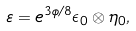Convert formula to latex. <formula><loc_0><loc_0><loc_500><loc_500>\varepsilon = e ^ { 3 \phi / 8 } \epsilon _ { 0 } \otimes \eta _ { 0 } ,</formula> 